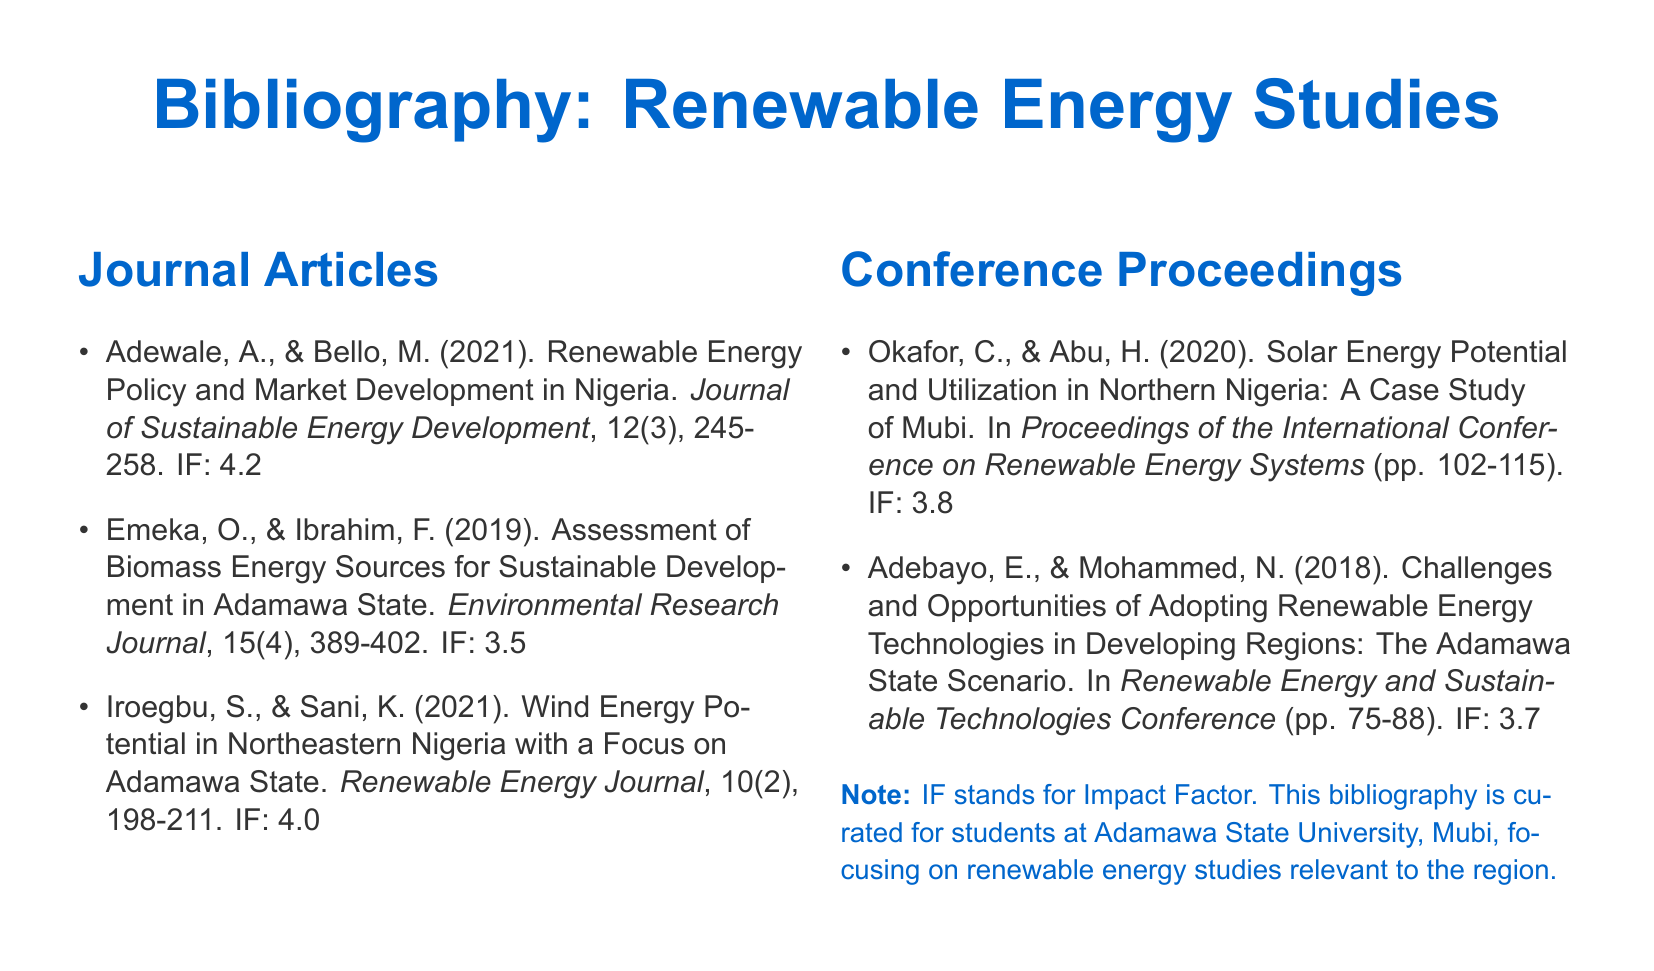What is the impact factor of the journal article by Adewale and Bello? The impact factor is mentioned after the citation of the journal article, which is 4.2.
Answer: 4.2 Which conference proceedings discusses solar energy in Northern Nigeria? The proceedings are listed under conference proceedings, specifically titled "Solar Energy Potential and Utilization in Northern Nigeria: A Case Study of Mubi."
Answer: Proceedings of the International Conference on Renewable Energy Systems What is the publication year of the article by Emeka and Ibrahim? The publication year is part of the citation for the article by Emeka and Ibrahim, noted as 2019.
Answer: 2019 How many articles are listed in the Journal Articles section? The document clearly lists three journal articles under the Journal Articles section.
Answer: 3 What common theme is addressed by the studies in this bibliography? The bibliography focuses on various aspects related to renewable energy studies, particularly in Adamawa State and Nigeria.
Answer: Renewable energy studies 